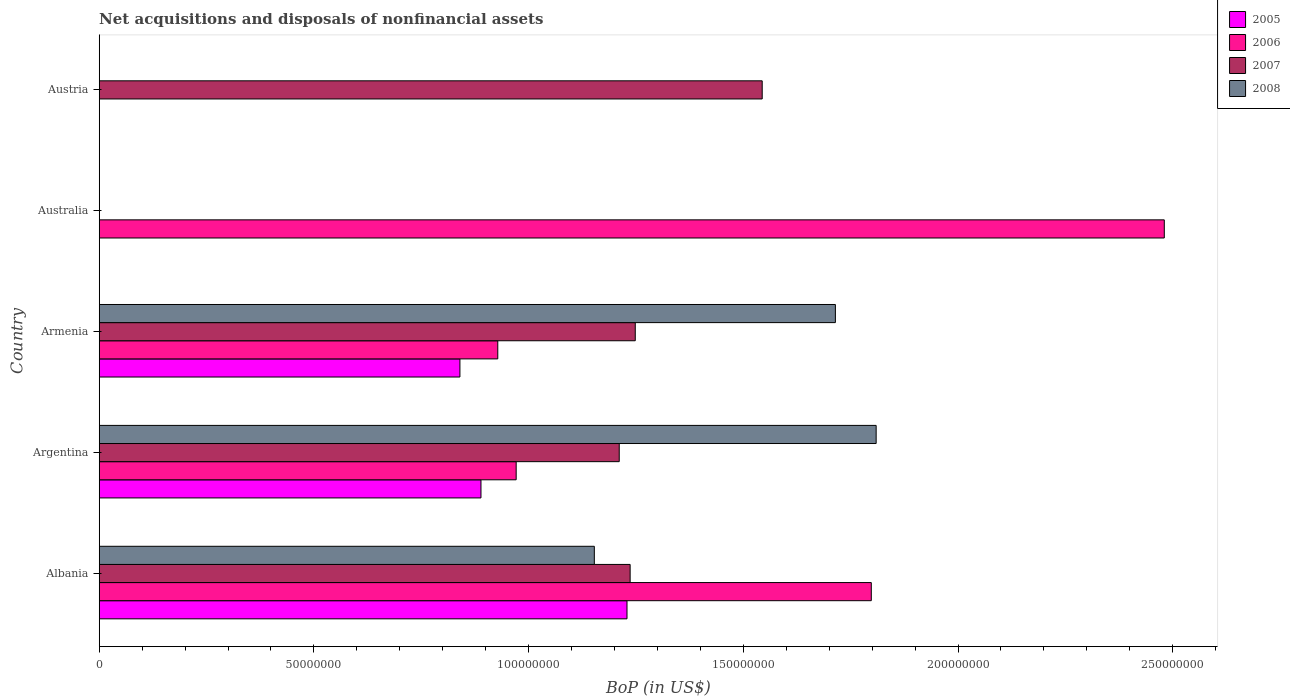How many different coloured bars are there?
Your answer should be compact. 4. How many bars are there on the 2nd tick from the top?
Your response must be concise. 1. What is the label of the 3rd group of bars from the top?
Your answer should be very brief. Armenia. In how many cases, is the number of bars for a given country not equal to the number of legend labels?
Provide a short and direct response. 2. What is the Balance of Payments in 2005 in Argentina?
Your answer should be very brief. 8.89e+07. Across all countries, what is the maximum Balance of Payments in 2005?
Keep it short and to the point. 1.23e+08. What is the total Balance of Payments in 2006 in the graph?
Give a very brief answer. 6.18e+08. What is the difference between the Balance of Payments in 2007 in Armenia and that in Austria?
Your answer should be compact. -2.96e+07. What is the difference between the Balance of Payments in 2005 in Austria and the Balance of Payments in 2006 in Armenia?
Keep it short and to the point. -9.28e+07. What is the average Balance of Payments in 2007 per country?
Keep it short and to the point. 1.05e+08. What is the difference between the Balance of Payments in 2008 and Balance of Payments in 2005 in Argentina?
Offer a terse response. 9.20e+07. In how many countries, is the Balance of Payments in 2007 greater than 50000000 US$?
Offer a terse response. 4. What is the ratio of the Balance of Payments in 2007 in Albania to that in Argentina?
Give a very brief answer. 1.02. Is the Balance of Payments in 2007 in Albania less than that in Armenia?
Your response must be concise. Yes. What is the difference between the highest and the second highest Balance of Payments in 2006?
Provide a succinct answer. 6.82e+07. What is the difference between the highest and the lowest Balance of Payments in 2007?
Make the answer very short. 1.54e+08. In how many countries, is the Balance of Payments in 2007 greater than the average Balance of Payments in 2007 taken over all countries?
Make the answer very short. 4. Is it the case that in every country, the sum of the Balance of Payments in 2007 and Balance of Payments in 2008 is greater than the sum of Balance of Payments in 2005 and Balance of Payments in 2006?
Provide a succinct answer. No. Is it the case that in every country, the sum of the Balance of Payments in 2005 and Balance of Payments in 2008 is greater than the Balance of Payments in 2006?
Provide a short and direct response. No. How many bars are there?
Give a very brief answer. 14. Are all the bars in the graph horizontal?
Your response must be concise. Yes. What is the difference between two consecutive major ticks on the X-axis?
Your answer should be compact. 5.00e+07. Are the values on the major ticks of X-axis written in scientific E-notation?
Provide a succinct answer. No. Does the graph contain any zero values?
Provide a short and direct response. Yes. How are the legend labels stacked?
Offer a very short reply. Vertical. What is the title of the graph?
Your answer should be very brief. Net acquisitions and disposals of nonfinancial assets. Does "2010" appear as one of the legend labels in the graph?
Provide a succinct answer. No. What is the label or title of the X-axis?
Offer a terse response. BoP (in US$). What is the BoP (in US$) of 2005 in Albania?
Keep it short and to the point. 1.23e+08. What is the BoP (in US$) of 2006 in Albania?
Your answer should be very brief. 1.80e+08. What is the BoP (in US$) of 2007 in Albania?
Your response must be concise. 1.24e+08. What is the BoP (in US$) in 2008 in Albania?
Your answer should be very brief. 1.15e+08. What is the BoP (in US$) in 2005 in Argentina?
Your answer should be compact. 8.89e+07. What is the BoP (in US$) of 2006 in Argentina?
Your answer should be very brief. 9.71e+07. What is the BoP (in US$) in 2007 in Argentina?
Offer a very short reply. 1.21e+08. What is the BoP (in US$) in 2008 in Argentina?
Your response must be concise. 1.81e+08. What is the BoP (in US$) of 2005 in Armenia?
Your answer should be very brief. 8.40e+07. What is the BoP (in US$) in 2006 in Armenia?
Offer a very short reply. 9.28e+07. What is the BoP (in US$) in 2007 in Armenia?
Offer a very short reply. 1.25e+08. What is the BoP (in US$) in 2008 in Armenia?
Ensure brevity in your answer.  1.71e+08. What is the BoP (in US$) in 2005 in Australia?
Offer a terse response. 0. What is the BoP (in US$) of 2006 in Australia?
Offer a terse response. 2.48e+08. What is the BoP (in US$) of 2007 in Australia?
Offer a very short reply. 0. What is the BoP (in US$) in 2006 in Austria?
Your answer should be compact. 0. What is the BoP (in US$) of 2007 in Austria?
Make the answer very short. 1.54e+08. What is the BoP (in US$) in 2008 in Austria?
Give a very brief answer. 0. Across all countries, what is the maximum BoP (in US$) of 2005?
Offer a very short reply. 1.23e+08. Across all countries, what is the maximum BoP (in US$) of 2006?
Make the answer very short. 2.48e+08. Across all countries, what is the maximum BoP (in US$) in 2007?
Provide a succinct answer. 1.54e+08. Across all countries, what is the maximum BoP (in US$) in 2008?
Your answer should be compact. 1.81e+08. Across all countries, what is the minimum BoP (in US$) of 2005?
Provide a succinct answer. 0. Across all countries, what is the minimum BoP (in US$) in 2007?
Provide a short and direct response. 0. Across all countries, what is the minimum BoP (in US$) of 2008?
Give a very brief answer. 0. What is the total BoP (in US$) in 2005 in the graph?
Offer a terse response. 2.96e+08. What is the total BoP (in US$) in 2006 in the graph?
Your answer should be compact. 6.18e+08. What is the total BoP (in US$) in 2007 in the graph?
Make the answer very short. 5.24e+08. What is the total BoP (in US$) of 2008 in the graph?
Ensure brevity in your answer.  4.68e+08. What is the difference between the BoP (in US$) in 2005 in Albania and that in Argentina?
Offer a very short reply. 3.40e+07. What is the difference between the BoP (in US$) in 2006 in Albania and that in Argentina?
Offer a very short reply. 8.27e+07. What is the difference between the BoP (in US$) of 2007 in Albania and that in Argentina?
Offer a terse response. 2.54e+06. What is the difference between the BoP (in US$) of 2008 in Albania and that in Argentina?
Your answer should be very brief. -6.56e+07. What is the difference between the BoP (in US$) of 2005 in Albania and that in Armenia?
Provide a succinct answer. 3.89e+07. What is the difference between the BoP (in US$) of 2006 in Albania and that in Armenia?
Your response must be concise. 8.70e+07. What is the difference between the BoP (in US$) of 2007 in Albania and that in Armenia?
Your answer should be very brief. -1.19e+06. What is the difference between the BoP (in US$) of 2008 in Albania and that in Armenia?
Offer a very short reply. -5.61e+07. What is the difference between the BoP (in US$) of 2006 in Albania and that in Australia?
Give a very brief answer. -6.82e+07. What is the difference between the BoP (in US$) in 2007 in Albania and that in Austria?
Make the answer very short. -3.08e+07. What is the difference between the BoP (in US$) in 2005 in Argentina and that in Armenia?
Ensure brevity in your answer.  4.90e+06. What is the difference between the BoP (in US$) of 2006 in Argentina and that in Armenia?
Give a very brief answer. 4.29e+06. What is the difference between the BoP (in US$) of 2007 in Argentina and that in Armenia?
Give a very brief answer. -3.73e+06. What is the difference between the BoP (in US$) in 2008 in Argentina and that in Armenia?
Offer a very short reply. 9.49e+06. What is the difference between the BoP (in US$) of 2006 in Argentina and that in Australia?
Provide a succinct answer. -1.51e+08. What is the difference between the BoP (in US$) of 2007 in Argentina and that in Austria?
Offer a terse response. -3.33e+07. What is the difference between the BoP (in US$) in 2006 in Armenia and that in Australia?
Offer a terse response. -1.55e+08. What is the difference between the BoP (in US$) in 2007 in Armenia and that in Austria?
Your answer should be compact. -2.96e+07. What is the difference between the BoP (in US$) of 2005 in Albania and the BoP (in US$) of 2006 in Argentina?
Keep it short and to the point. 2.58e+07. What is the difference between the BoP (in US$) of 2005 in Albania and the BoP (in US$) of 2007 in Argentina?
Keep it short and to the point. 1.81e+06. What is the difference between the BoP (in US$) of 2005 in Albania and the BoP (in US$) of 2008 in Argentina?
Provide a succinct answer. -5.80e+07. What is the difference between the BoP (in US$) in 2006 in Albania and the BoP (in US$) in 2007 in Argentina?
Make the answer very short. 5.87e+07. What is the difference between the BoP (in US$) in 2006 in Albania and the BoP (in US$) in 2008 in Argentina?
Make the answer very short. -1.13e+06. What is the difference between the BoP (in US$) of 2007 in Albania and the BoP (in US$) of 2008 in Argentina?
Provide a succinct answer. -5.73e+07. What is the difference between the BoP (in US$) of 2005 in Albania and the BoP (in US$) of 2006 in Armenia?
Provide a short and direct response. 3.01e+07. What is the difference between the BoP (in US$) of 2005 in Albania and the BoP (in US$) of 2007 in Armenia?
Keep it short and to the point. -1.92e+06. What is the difference between the BoP (in US$) in 2005 in Albania and the BoP (in US$) in 2008 in Armenia?
Your response must be concise. -4.85e+07. What is the difference between the BoP (in US$) of 2006 in Albania and the BoP (in US$) of 2007 in Armenia?
Provide a succinct answer. 5.50e+07. What is the difference between the BoP (in US$) of 2006 in Albania and the BoP (in US$) of 2008 in Armenia?
Your answer should be compact. 8.36e+06. What is the difference between the BoP (in US$) in 2007 in Albania and the BoP (in US$) in 2008 in Armenia?
Offer a very short reply. -4.78e+07. What is the difference between the BoP (in US$) in 2005 in Albania and the BoP (in US$) in 2006 in Australia?
Keep it short and to the point. -1.25e+08. What is the difference between the BoP (in US$) of 2005 in Albania and the BoP (in US$) of 2007 in Austria?
Give a very brief answer. -3.15e+07. What is the difference between the BoP (in US$) of 2006 in Albania and the BoP (in US$) of 2007 in Austria?
Offer a terse response. 2.54e+07. What is the difference between the BoP (in US$) in 2005 in Argentina and the BoP (in US$) in 2006 in Armenia?
Your response must be concise. -3.91e+06. What is the difference between the BoP (in US$) of 2005 in Argentina and the BoP (in US$) of 2007 in Armenia?
Offer a very short reply. -3.59e+07. What is the difference between the BoP (in US$) in 2005 in Argentina and the BoP (in US$) in 2008 in Armenia?
Offer a very short reply. -8.25e+07. What is the difference between the BoP (in US$) in 2006 in Argentina and the BoP (in US$) in 2007 in Armenia?
Provide a short and direct response. -2.77e+07. What is the difference between the BoP (in US$) in 2006 in Argentina and the BoP (in US$) in 2008 in Armenia?
Keep it short and to the point. -7.43e+07. What is the difference between the BoP (in US$) in 2007 in Argentina and the BoP (in US$) in 2008 in Armenia?
Offer a terse response. -5.03e+07. What is the difference between the BoP (in US$) of 2005 in Argentina and the BoP (in US$) of 2006 in Australia?
Make the answer very short. -1.59e+08. What is the difference between the BoP (in US$) of 2005 in Argentina and the BoP (in US$) of 2007 in Austria?
Make the answer very short. -6.55e+07. What is the difference between the BoP (in US$) of 2006 in Argentina and the BoP (in US$) of 2007 in Austria?
Your answer should be very brief. -5.73e+07. What is the difference between the BoP (in US$) in 2005 in Armenia and the BoP (in US$) in 2006 in Australia?
Offer a terse response. -1.64e+08. What is the difference between the BoP (in US$) of 2005 in Armenia and the BoP (in US$) of 2007 in Austria?
Make the answer very short. -7.04e+07. What is the difference between the BoP (in US$) in 2006 in Armenia and the BoP (in US$) in 2007 in Austria?
Provide a short and direct response. -6.16e+07. What is the difference between the BoP (in US$) of 2006 in Australia and the BoP (in US$) of 2007 in Austria?
Ensure brevity in your answer.  9.36e+07. What is the average BoP (in US$) of 2005 per country?
Offer a very short reply. 5.92e+07. What is the average BoP (in US$) of 2006 per country?
Offer a very short reply. 1.24e+08. What is the average BoP (in US$) in 2007 per country?
Your answer should be very brief. 1.05e+08. What is the average BoP (in US$) of 2008 per country?
Offer a terse response. 9.35e+07. What is the difference between the BoP (in US$) of 2005 and BoP (in US$) of 2006 in Albania?
Give a very brief answer. -5.69e+07. What is the difference between the BoP (in US$) of 2005 and BoP (in US$) of 2007 in Albania?
Offer a terse response. -7.29e+05. What is the difference between the BoP (in US$) in 2005 and BoP (in US$) in 2008 in Albania?
Your answer should be compact. 7.61e+06. What is the difference between the BoP (in US$) of 2006 and BoP (in US$) of 2007 in Albania?
Provide a succinct answer. 5.62e+07. What is the difference between the BoP (in US$) of 2006 and BoP (in US$) of 2008 in Albania?
Offer a very short reply. 6.45e+07. What is the difference between the BoP (in US$) of 2007 and BoP (in US$) of 2008 in Albania?
Offer a very short reply. 8.34e+06. What is the difference between the BoP (in US$) of 2005 and BoP (in US$) of 2006 in Argentina?
Your response must be concise. -8.20e+06. What is the difference between the BoP (in US$) in 2005 and BoP (in US$) in 2007 in Argentina?
Your response must be concise. -3.22e+07. What is the difference between the BoP (in US$) of 2005 and BoP (in US$) of 2008 in Argentina?
Make the answer very short. -9.20e+07. What is the difference between the BoP (in US$) of 2006 and BoP (in US$) of 2007 in Argentina?
Your answer should be very brief. -2.40e+07. What is the difference between the BoP (in US$) of 2006 and BoP (in US$) of 2008 in Argentina?
Your response must be concise. -8.38e+07. What is the difference between the BoP (in US$) of 2007 and BoP (in US$) of 2008 in Argentina?
Your response must be concise. -5.98e+07. What is the difference between the BoP (in US$) of 2005 and BoP (in US$) of 2006 in Armenia?
Provide a short and direct response. -8.81e+06. What is the difference between the BoP (in US$) in 2005 and BoP (in US$) in 2007 in Armenia?
Provide a short and direct response. -4.08e+07. What is the difference between the BoP (in US$) in 2005 and BoP (in US$) in 2008 in Armenia?
Keep it short and to the point. -8.74e+07. What is the difference between the BoP (in US$) in 2006 and BoP (in US$) in 2007 in Armenia?
Your response must be concise. -3.20e+07. What is the difference between the BoP (in US$) of 2006 and BoP (in US$) of 2008 in Armenia?
Your answer should be very brief. -7.86e+07. What is the difference between the BoP (in US$) of 2007 and BoP (in US$) of 2008 in Armenia?
Provide a succinct answer. -4.66e+07. What is the ratio of the BoP (in US$) in 2005 in Albania to that in Argentina?
Provide a succinct answer. 1.38. What is the ratio of the BoP (in US$) in 2006 in Albania to that in Argentina?
Offer a very short reply. 1.85. What is the ratio of the BoP (in US$) of 2007 in Albania to that in Argentina?
Give a very brief answer. 1.02. What is the ratio of the BoP (in US$) in 2008 in Albania to that in Argentina?
Your answer should be very brief. 0.64. What is the ratio of the BoP (in US$) of 2005 in Albania to that in Armenia?
Your answer should be very brief. 1.46. What is the ratio of the BoP (in US$) of 2006 in Albania to that in Armenia?
Ensure brevity in your answer.  1.94. What is the ratio of the BoP (in US$) in 2007 in Albania to that in Armenia?
Make the answer very short. 0.99. What is the ratio of the BoP (in US$) in 2008 in Albania to that in Armenia?
Offer a very short reply. 0.67. What is the ratio of the BoP (in US$) in 2006 in Albania to that in Australia?
Offer a very short reply. 0.72. What is the ratio of the BoP (in US$) in 2007 in Albania to that in Austria?
Your response must be concise. 0.8. What is the ratio of the BoP (in US$) in 2005 in Argentina to that in Armenia?
Make the answer very short. 1.06. What is the ratio of the BoP (in US$) of 2006 in Argentina to that in Armenia?
Your answer should be compact. 1.05. What is the ratio of the BoP (in US$) in 2007 in Argentina to that in Armenia?
Provide a succinct answer. 0.97. What is the ratio of the BoP (in US$) in 2008 in Argentina to that in Armenia?
Make the answer very short. 1.06. What is the ratio of the BoP (in US$) in 2006 in Argentina to that in Australia?
Keep it short and to the point. 0.39. What is the ratio of the BoP (in US$) of 2007 in Argentina to that in Austria?
Offer a very short reply. 0.78. What is the ratio of the BoP (in US$) in 2006 in Armenia to that in Australia?
Offer a very short reply. 0.37. What is the ratio of the BoP (in US$) in 2007 in Armenia to that in Austria?
Your answer should be very brief. 0.81. What is the difference between the highest and the second highest BoP (in US$) in 2005?
Offer a terse response. 3.40e+07. What is the difference between the highest and the second highest BoP (in US$) of 2006?
Make the answer very short. 6.82e+07. What is the difference between the highest and the second highest BoP (in US$) in 2007?
Provide a succinct answer. 2.96e+07. What is the difference between the highest and the second highest BoP (in US$) in 2008?
Give a very brief answer. 9.49e+06. What is the difference between the highest and the lowest BoP (in US$) in 2005?
Your answer should be very brief. 1.23e+08. What is the difference between the highest and the lowest BoP (in US$) in 2006?
Offer a terse response. 2.48e+08. What is the difference between the highest and the lowest BoP (in US$) in 2007?
Provide a succinct answer. 1.54e+08. What is the difference between the highest and the lowest BoP (in US$) in 2008?
Ensure brevity in your answer.  1.81e+08. 